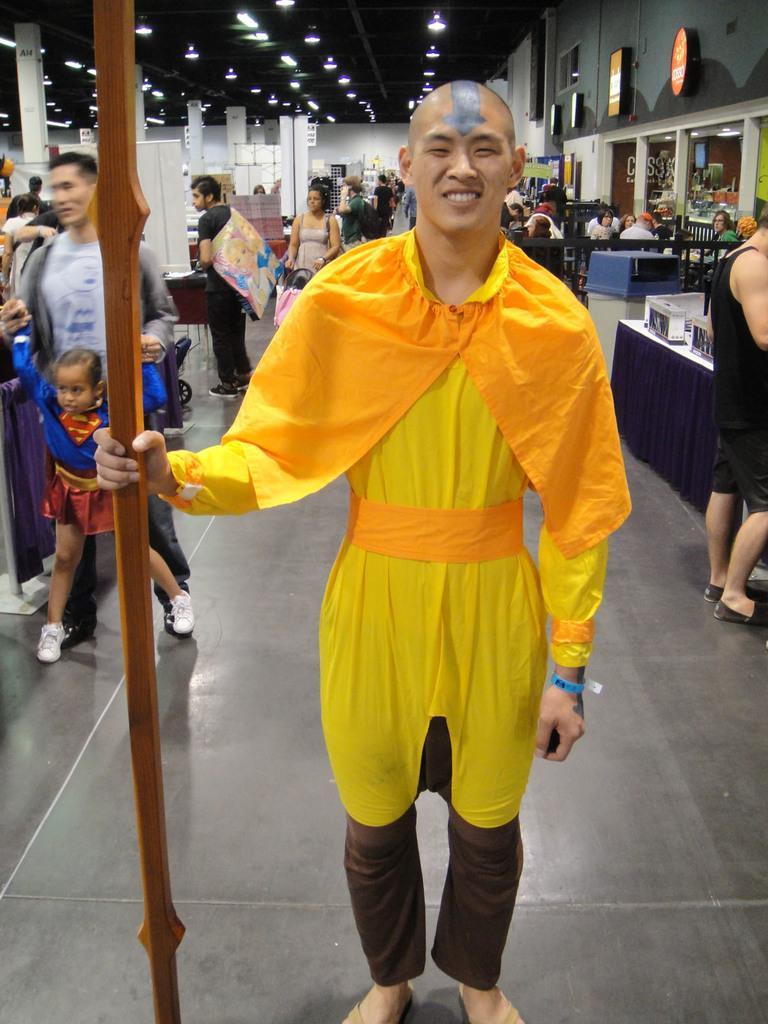Can you describe this image briefly? In the center of the image we can see one person is standing and he is holding one wooden object. And we can see he is smiling, which we can see on his face. And he is in yellow and brown colored costume and we can see some ash color paint on his forehead. In the background there is a wall, lights, banners, pillars, one blue and white color object, tables, chairs, few people are sitting, few people are standing, few people are holding some objects and a few other objects. 